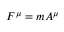Convert formula to latex. <formula><loc_0><loc_0><loc_500><loc_500>F ^ { \mu } = m A ^ { \mu }</formula> 